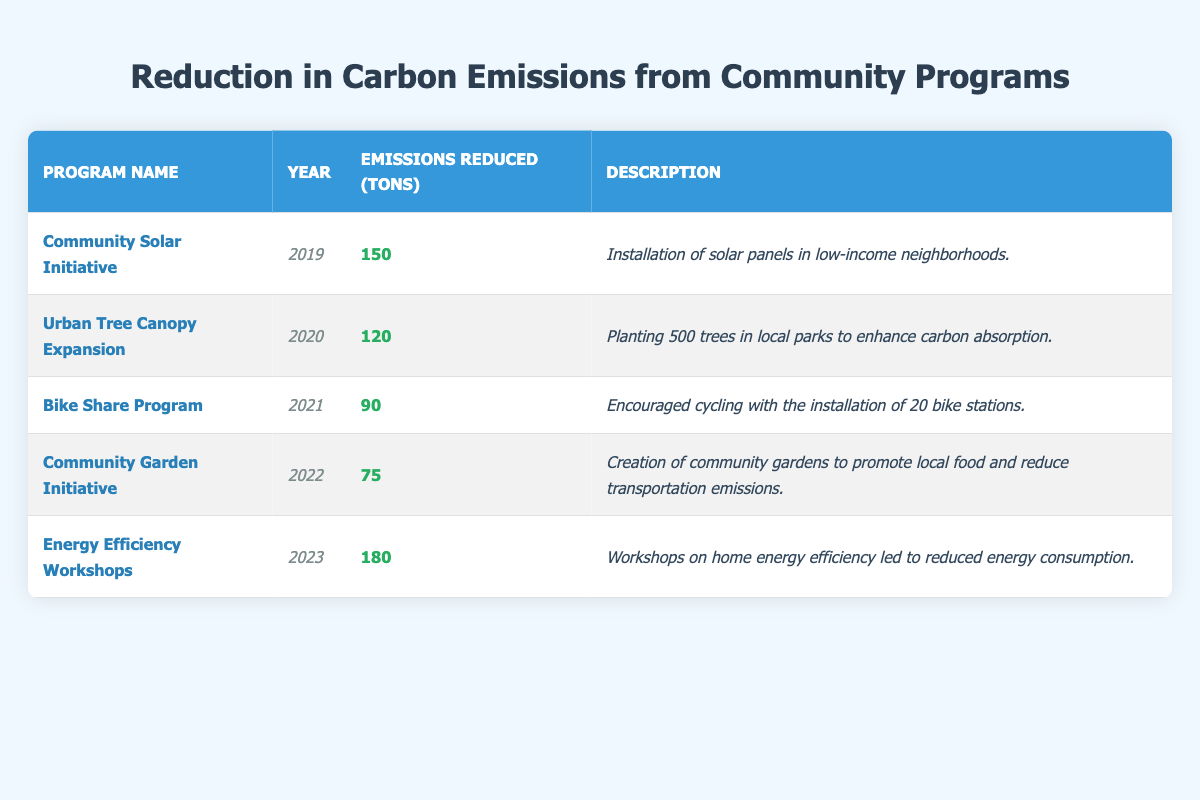What was the total emissions reduced by the Community Solar Initiative? The table shows that the Community Solar Initiative reduced 150 tons of emissions in 2019.
Answer: 150 tons Which program had the highest emissions reduction in 2023? The Energy Efficiency Workshops program is listed for 2023 with emissions reduced amounting to 180 tons, which is the highest of that year.
Answer: Energy Efficiency Workshops What is the average emissions reduction over the five years? To find the average: sum the emissions reduced (150 + 120 + 90 + 75 + 180 = 615) and divide by the number of programs (5), so the average is 615 / 5 = 123.
Answer: 123 tons Did the Bike Share Program reduce more emissions than the Community Garden Initiative? The Bike Share Program reduced 90 tons, while the Community Garden Initiative reduced 75 tons; since 90 is greater than 75, the statement is true.
Answer: Yes Which program contributed the least to emissions reduction, and what was the amount? By comparing the emissions reductions, the program with the least reduction is the Community Garden Initiative, with 75 tons.
Answer: Community Garden Initiative, 75 tons What is the total emissions reduced from 2019 to 2022? The emissions reduced from 2019 to 2022 are 150 + 120 + 90 + 75 = 435 tons, which is the total emissions reduction over those years.
Answer: 435 tons How many tons of emissions were reduced in the years 2021 and 2022 combined? For 2021, emissions reduced were 90 tons and for 2022 it was 75 tons; combining these gives 90 + 75 = 165 tons.
Answer: 165 tons Was the Urban Tree Canopy Expansion more effective than the Bike Share Program? The Urban Tree Canopy Expansion reduced 120 tons, while the Bike Share Program reduced 90 tons; therefore, the Urban Tree Canopy Expansion was more effective.
Answer: Yes What percentage of the total emissions reduction over the five years did the Energy Efficiency Workshops represent? The total emissions reduction is 615 tons, and for the Energy Efficiency Workshops, it’s 180 tons; the percentage is (180/615) * 100 ≈ 29.27%.
Answer: Approximately 29.27% Which year saw the lowest emissions reduction, and what was the amount? The year 2022 saw the lowest emissions reduction at 75 tons from the Community Garden Initiative.
Answer: 2022, 75 tons 